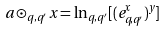<formula> <loc_0><loc_0><loc_500><loc_500>a \odot _ { q , q ^ { \prime } } x = \ln _ { q , q ^ { \prime } } [ ( e _ { q , q ^ { \prime } } ^ { x } ) ^ { y } ]</formula> 